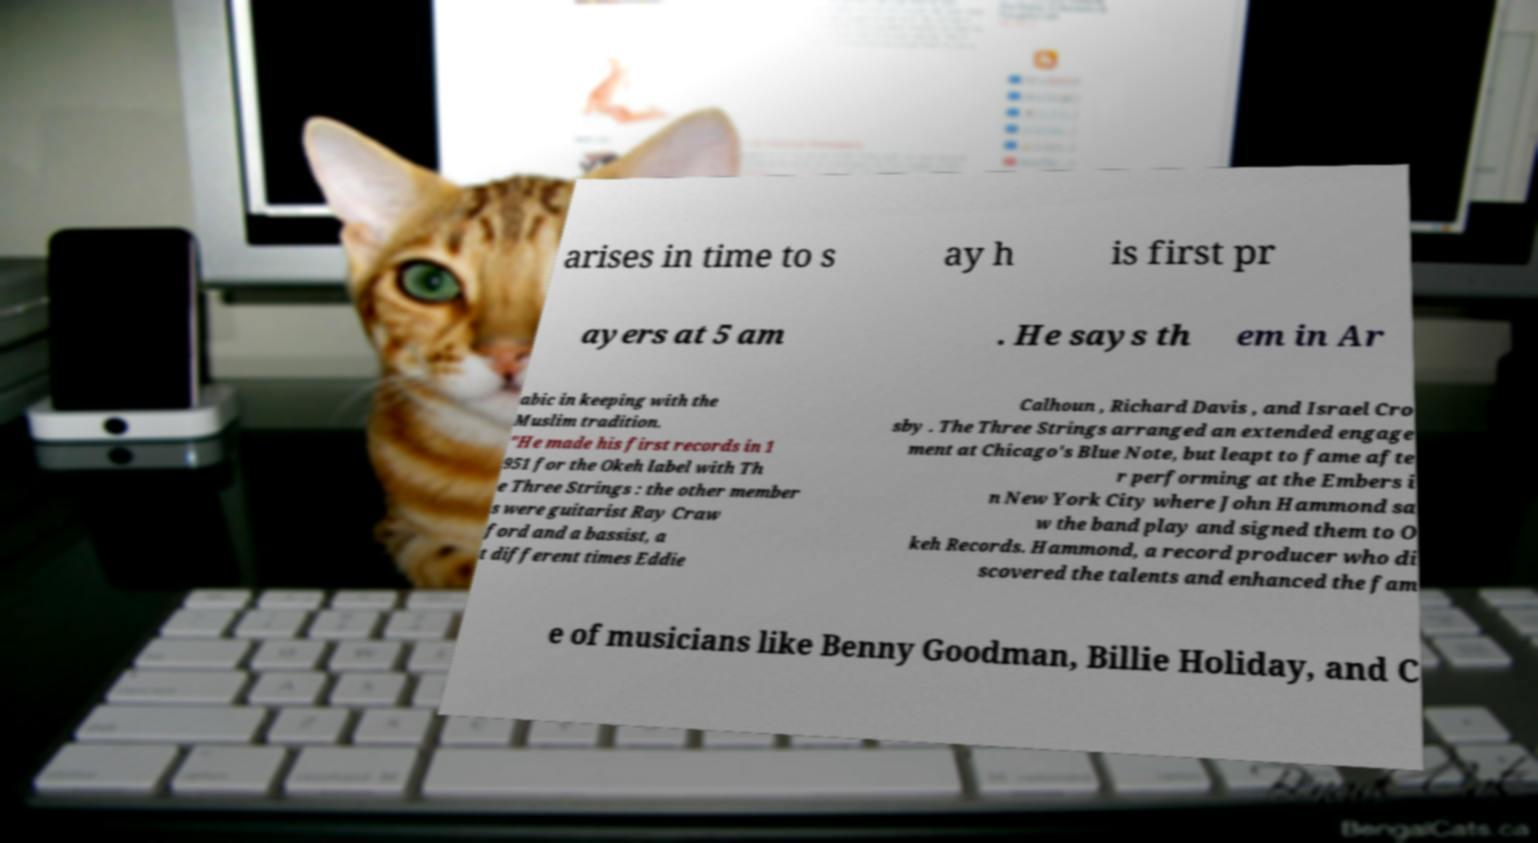Can you read and provide the text displayed in the image?This photo seems to have some interesting text. Can you extract and type it out for me? arises in time to s ay h is first pr ayers at 5 am . He says th em in Ar abic in keeping with the Muslim tradition. "He made his first records in 1 951 for the Okeh label with Th e Three Strings : the other member s were guitarist Ray Craw ford and a bassist, a t different times Eddie Calhoun , Richard Davis , and Israel Cro sby . The Three Strings arranged an extended engage ment at Chicago's Blue Note, but leapt to fame afte r performing at the Embers i n New York City where John Hammond sa w the band play and signed them to O keh Records. Hammond, a record producer who di scovered the talents and enhanced the fam e of musicians like Benny Goodman, Billie Holiday, and C 